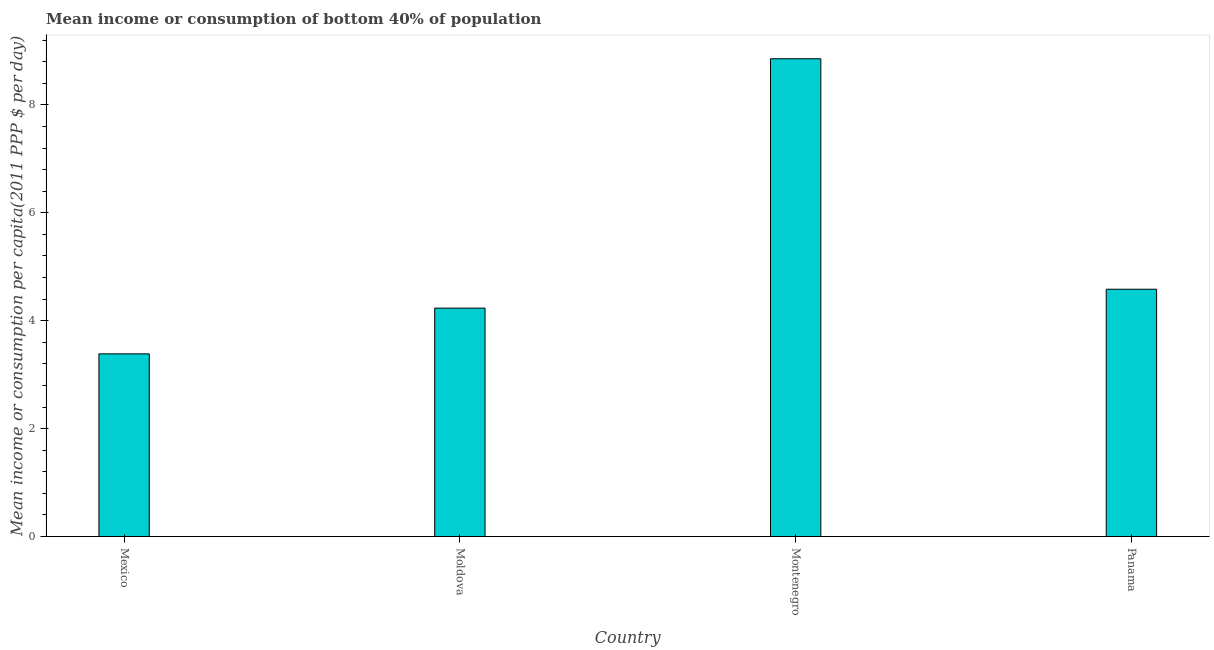What is the title of the graph?
Ensure brevity in your answer.  Mean income or consumption of bottom 40% of population. What is the label or title of the Y-axis?
Give a very brief answer. Mean income or consumption per capita(2011 PPP $ per day). What is the mean income or consumption in Mexico?
Your answer should be very brief. 3.39. Across all countries, what is the maximum mean income or consumption?
Offer a very short reply. 8.86. Across all countries, what is the minimum mean income or consumption?
Keep it short and to the point. 3.39. In which country was the mean income or consumption maximum?
Your answer should be very brief. Montenegro. What is the sum of the mean income or consumption?
Your response must be concise. 21.06. What is the difference between the mean income or consumption in Moldova and Montenegro?
Ensure brevity in your answer.  -4.62. What is the average mean income or consumption per country?
Offer a terse response. 5.26. What is the median mean income or consumption?
Your answer should be very brief. 4.41. What is the ratio of the mean income or consumption in Montenegro to that in Panama?
Provide a short and direct response. 1.93. Is the mean income or consumption in Moldova less than that in Montenegro?
Offer a terse response. Yes. What is the difference between the highest and the second highest mean income or consumption?
Ensure brevity in your answer.  4.27. Is the sum of the mean income or consumption in Mexico and Panama greater than the maximum mean income or consumption across all countries?
Give a very brief answer. No. What is the difference between the highest and the lowest mean income or consumption?
Offer a terse response. 5.47. What is the difference between two consecutive major ticks on the Y-axis?
Provide a succinct answer. 2. Are the values on the major ticks of Y-axis written in scientific E-notation?
Offer a terse response. No. What is the Mean income or consumption per capita(2011 PPP $ per day) of Mexico?
Provide a succinct answer. 3.39. What is the Mean income or consumption per capita(2011 PPP $ per day) of Moldova?
Your answer should be compact. 4.23. What is the Mean income or consumption per capita(2011 PPP $ per day) in Montenegro?
Make the answer very short. 8.86. What is the Mean income or consumption per capita(2011 PPP $ per day) of Panama?
Offer a terse response. 4.58. What is the difference between the Mean income or consumption per capita(2011 PPP $ per day) in Mexico and Moldova?
Offer a very short reply. -0.85. What is the difference between the Mean income or consumption per capita(2011 PPP $ per day) in Mexico and Montenegro?
Provide a succinct answer. -5.47. What is the difference between the Mean income or consumption per capita(2011 PPP $ per day) in Mexico and Panama?
Provide a succinct answer. -1.2. What is the difference between the Mean income or consumption per capita(2011 PPP $ per day) in Moldova and Montenegro?
Ensure brevity in your answer.  -4.62. What is the difference between the Mean income or consumption per capita(2011 PPP $ per day) in Moldova and Panama?
Give a very brief answer. -0.35. What is the difference between the Mean income or consumption per capita(2011 PPP $ per day) in Montenegro and Panama?
Make the answer very short. 4.27. What is the ratio of the Mean income or consumption per capita(2011 PPP $ per day) in Mexico to that in Montenegro?
Your answer should be very brief. 0.38. What is the ratio of the Mean income or consumption per capita(2011 PPP $ per day) in Mexico to that in Panama?
Your answer should be compact. 0.74. What is the ratio of the Mean income or consumption per capita(2011 PPP $ per day) in Moldova to that in Montenegro?
Ensure brevity in your answer.  0.48. What is the ratio of the Mean income or consumption per capita(2011 PPP $ per day) in Moldova to that in Panama?
Provide a short and direct response. 0.92. What is the ratio of the Mean income or consumption per capita(2011 PPP $ per day) in Montenegro to that in Panama?
Give a very brief answer. 1.93. 